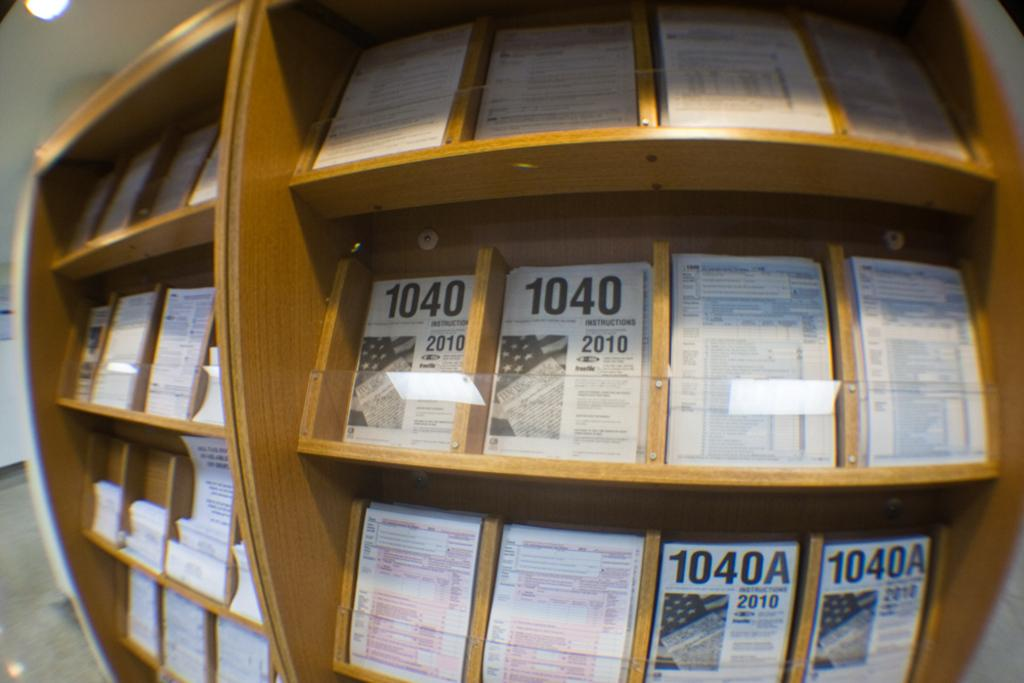<image>
Relay a brief, clear account of the picture shown. Shelf full of different framed papers including one from 2010. 